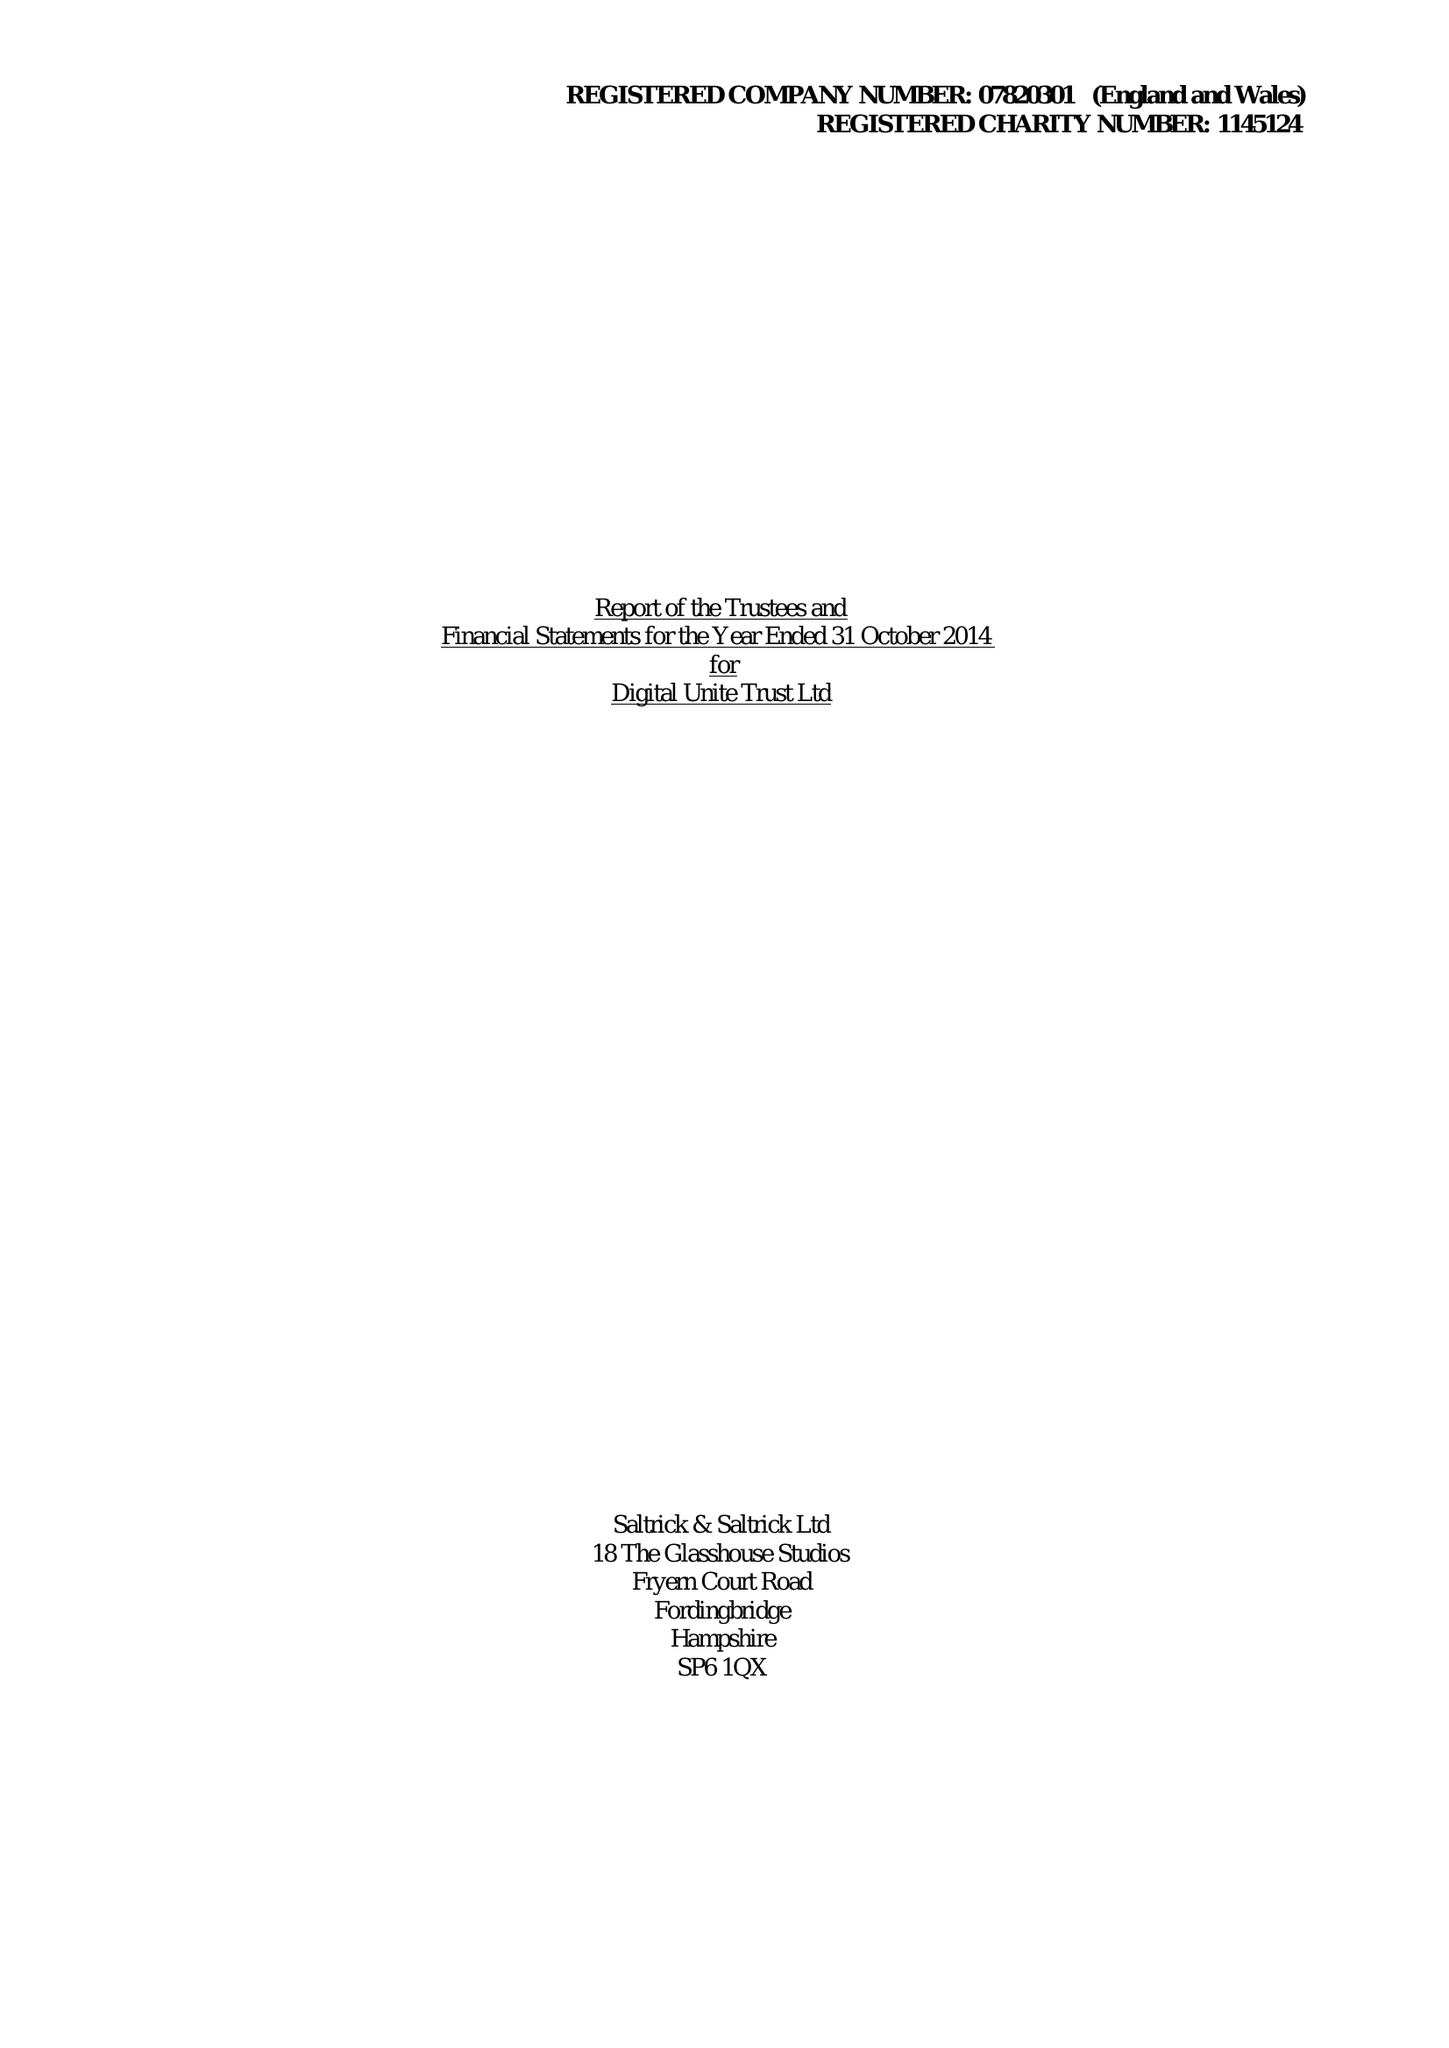What is the value for the report_date?
Answer the question using a single word or phrase. 2014-10-31 